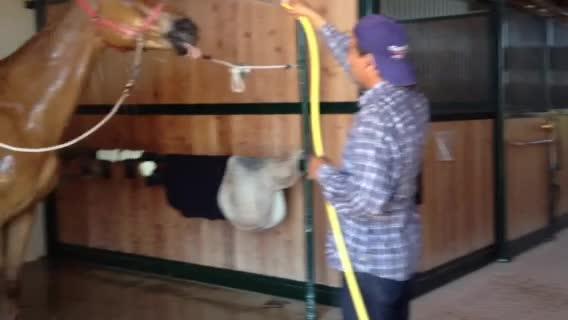Does this man's hat match well with his shirt?
Concise answer only. Yes. How many horses in the photo?
Concise answer only. 1. What is the man doing to the horse?
Concise answer only. Washing. 